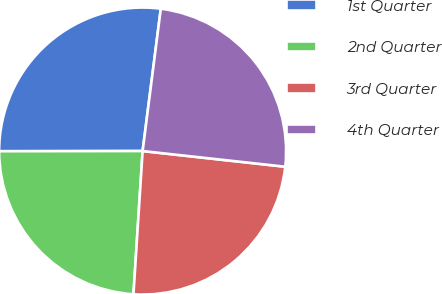<chart> <loc_0><loc_0><loc_500><loc_500><pie_chart><fcel>1st Quarter<fcel>2nd Quarter<fcel>3rd Quarter<fcel>4th Quarter<nl><fcel>27.04%<fcel>23.96%<fcel>24.27%<fcel>24.72%<nl></chart> 